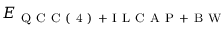Convert formula to latex. <formula><loc_0><loc_0><loc_500><loc_500>E _ { Q C C ( 4 ) + I L C A P + B W }</formula> 